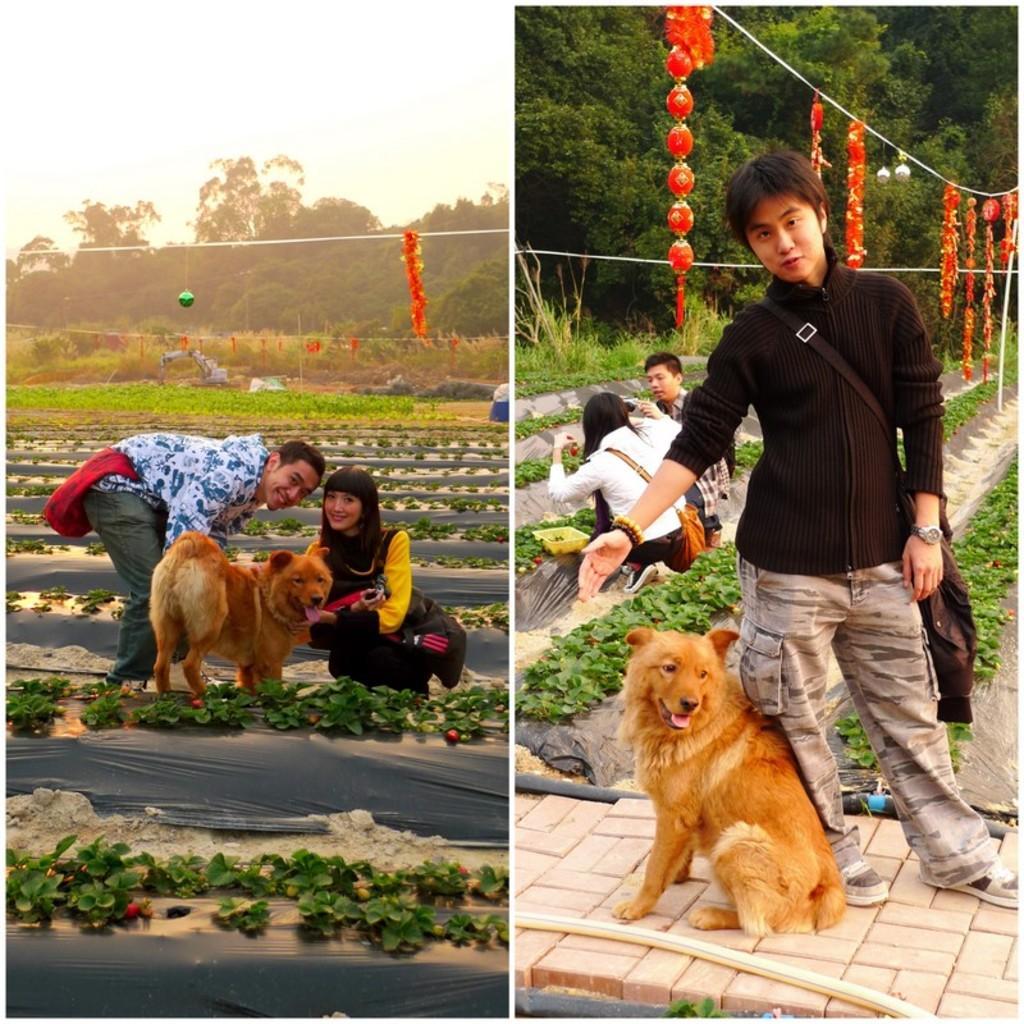How would you summarize this image in a sentence or two? This picture describes about collage of images, in this we can find group of people, dogs, few plants, trees and paper lanterns. 